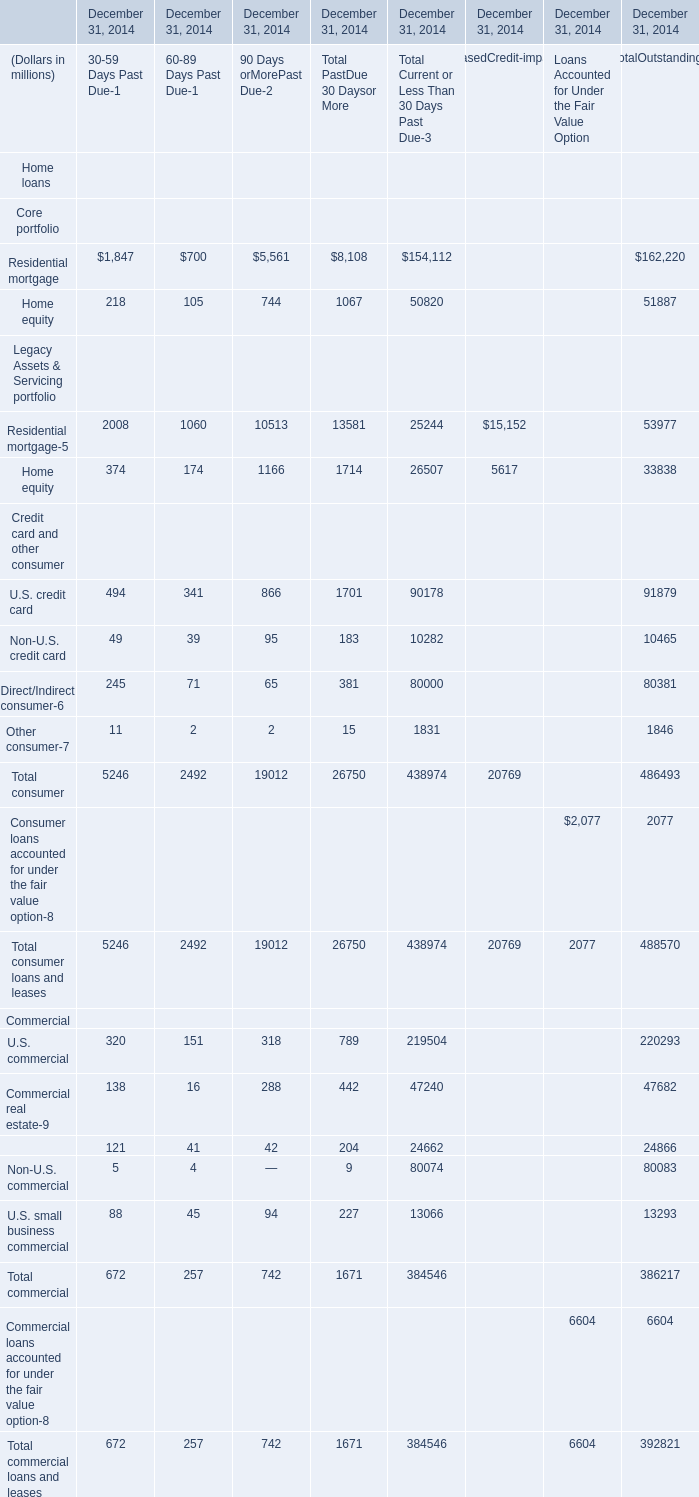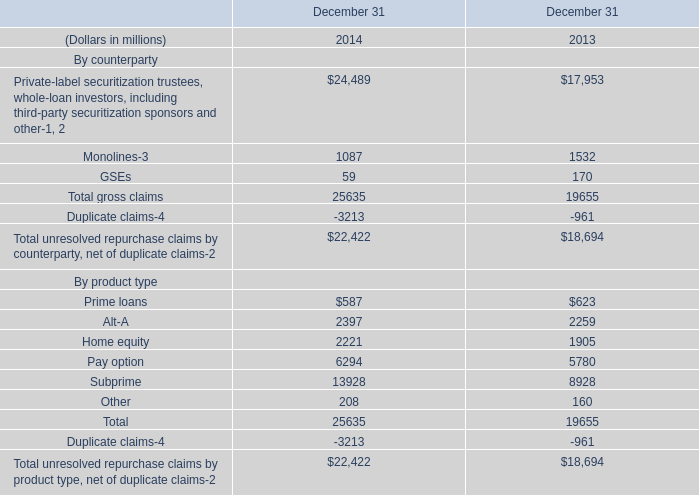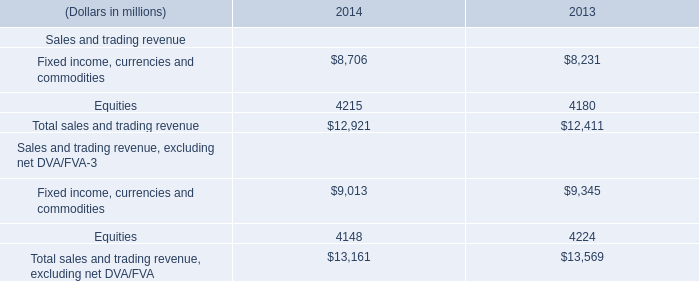What's the average of Fixed income, currencies and commodities of 2013, and Subprime By product type of December 31 2014 ? 
Computations: ((8231.0 + 13928.0) / 2)
Answer: 11079.5. 